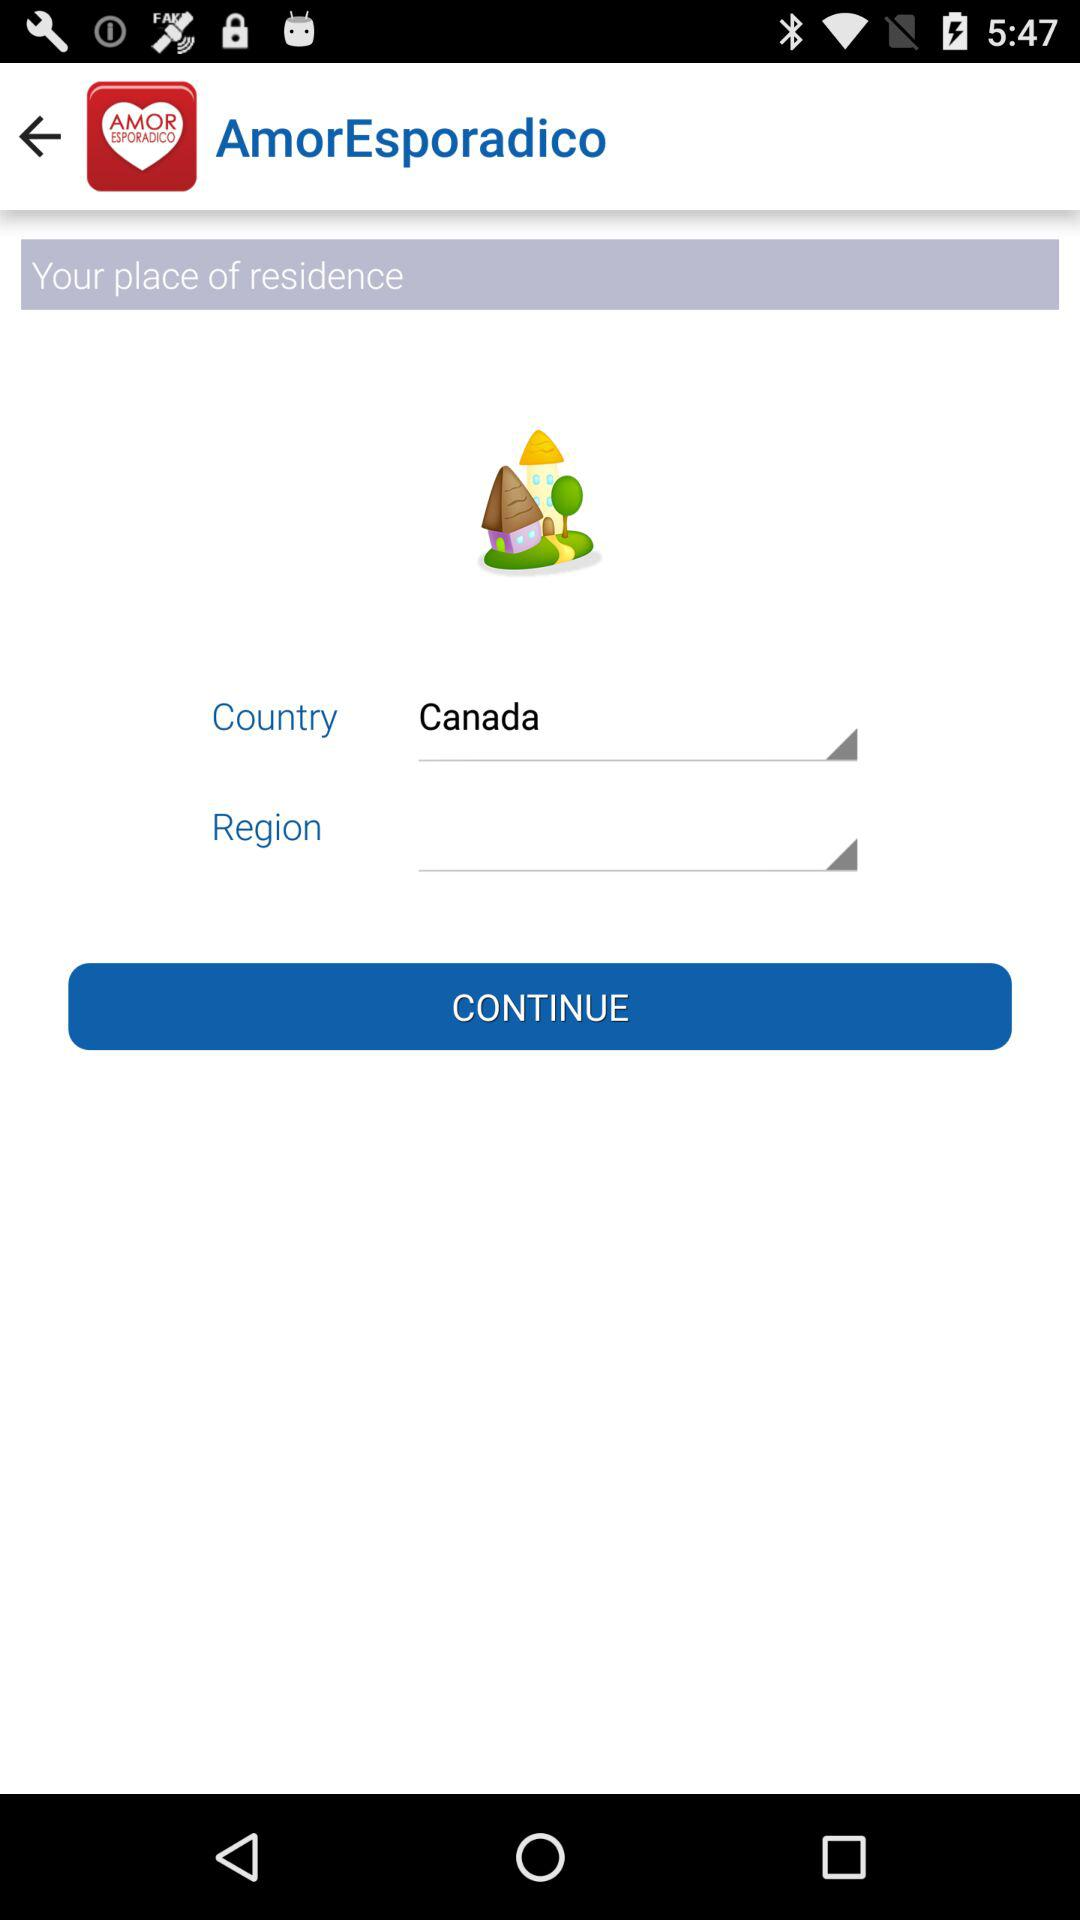What is the country's name? The country's name is Canada. 